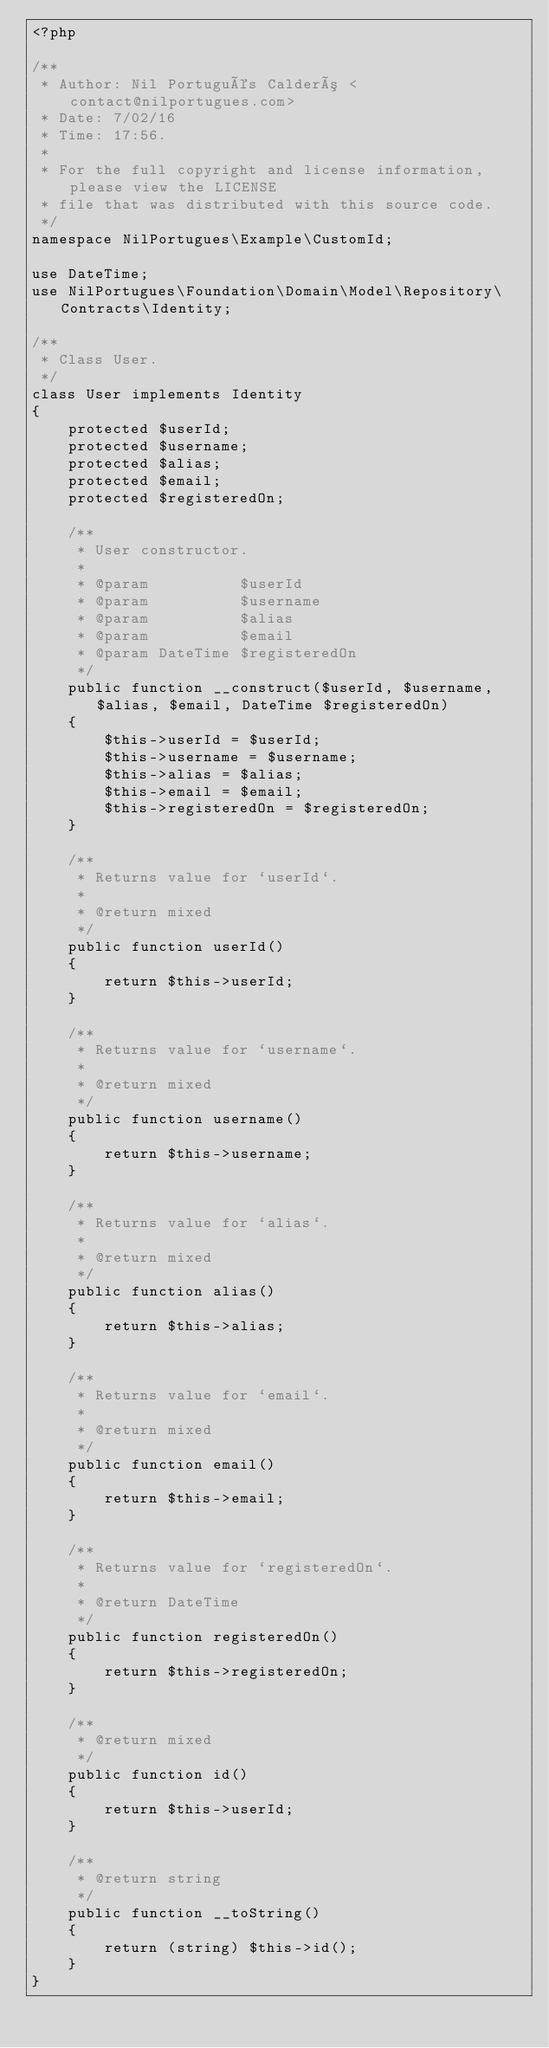Convert code to text. <code><loc_0><loc_0><loc_500><loc_500><_PHP_><?php

/**
 * Author: Nil Portugués Calderó <contact@nilportugues.com>
 * Date: 7/02/16
 * Time: 17:56.
 *
 * For the full copyright and license information, please view the LICENSE
 * file that was distributed with this source code.
 */
namespace NilPortugues\Example\CustomId;

use DateTime;
use NilPortugues\Foundation\Domain\Model\Repository\Contracts\Identity;

/**
 * Class User.
 */
class User implements Identity
{
    protected $userId;
    protected $username;
    protected $alias;
    protected $email;
    protected $registeredOn;

    /**
     * User constructor.
     *
     * @param          $userId
     * @param          $username
     * @param          $alias
     * @param          $email
     * @param DateTime $registeredOn
     */
    public function __construct($userId, $username, $alias, $email, DateTime $registeredOn)
    {
        $this->userId = $userId;
        $this->username = $username;
        $this->alias = $alias;
        $this->email = $email;
        $this->registeredOn = $registeredOn;
    }

    /**
     * Returns value for `userId`.
     *
     * @return mixed
     */
    public function userId()
    {
        return $this->userId;
    }

    /**
     * Returns value for `username`.
     *
     * @return mixed
     */
    public function username()
    {
        return $this->username;
    }

    /**
     * Returns value for `alias`.
     *
     * @return mixed
     */
    public function alias()
    {
        return $this->alias;
    }

    /**
     * Returns value for `email`.
     *
     * @return mixed
     */
    public function email()
    {
        return $this->email;
    }

    /**
     * Returns value for `registeredOn`.
     *
     * @return DateTime
     */
    public function registeredOn()
    {
        return $this->registeredOn;
    }

    /**
     * @return mixed
     */
    public function id()
    {
        return $this->userId;
    }

    /**
     * @return string
     */
    public function __toString()
    {
        return (string) $this->id();
    }
}
</code> 